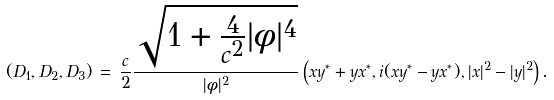<formula> <loc_0><loc_0><loc_500><loc_500>( D _ { 1 } , D _ { 2 } , D _ { 3 } ) \, = \, { \frac { c } { 2 } } { \frac { \sqrt { 1 + { \frac { 4 } { c ^ { 2 } } } | \phi | ^ { 4 } } } { | \phi | ^ { 2 } } } \left ( x y ^ { * } + y x ^ { * } , i ( x y ^ { * } - y x ^ { * } ) , | x | ^ { 2 } - | y | ^ { 2 } \right ) .</formula> 